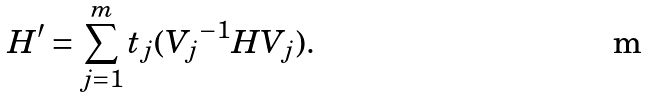Convert formula to latex. <formula><loc_0><loc_0><loc_500><loc_500>H ^ { \prime } = \sum _ { j = 1 } ^ { m } t _ { j } ( { V _ { j } } ^ { - 1 } H { V _ { j } } ) .</formula> 